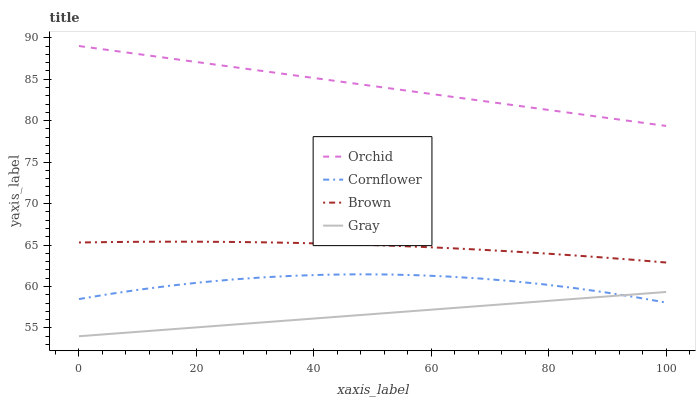Does Gray have the minimum area under the curve?
Answer yes or no. Yes. Does Orchid have the maximum area under the curve?
Answer yes or no. Yes. Does Brown have the minimum area under the curve?
Answer yes or no. No. Does Brown have the maximum area under the curve?
Answer yes or no. No. Is Gray the smoothest?
Answer yes or no. Yes. Is Cornflower the roughest?
Answer yes or no. Yes. Is Brown the smoothest?
Answer yes or no. No. Is Brown the roughest?
Answer yes or no. No. Does Gray have the lowest value?
Answer yes or no. Yes. Does Brown have the lowest value?
Answer yes or no. No. Does Orchid have the highest value?
Answer yes or no. Yes. Does Brown have the highest value?
Answer yes or no. No. Is Gray less than Orchid?
Answer yes or no. Yes. Is Orchid greater than Gray?
Answer yes or no. Yes. Does Cornflower intersect Gray?
Answer yes or no. Yes. Is Cornflower less than Gray?
Answer yes or no. No. Is Cornflower greater than Gray?
Answer yes or no. No. Does Gray intersect Orchid?
Answer yes or no. No. 